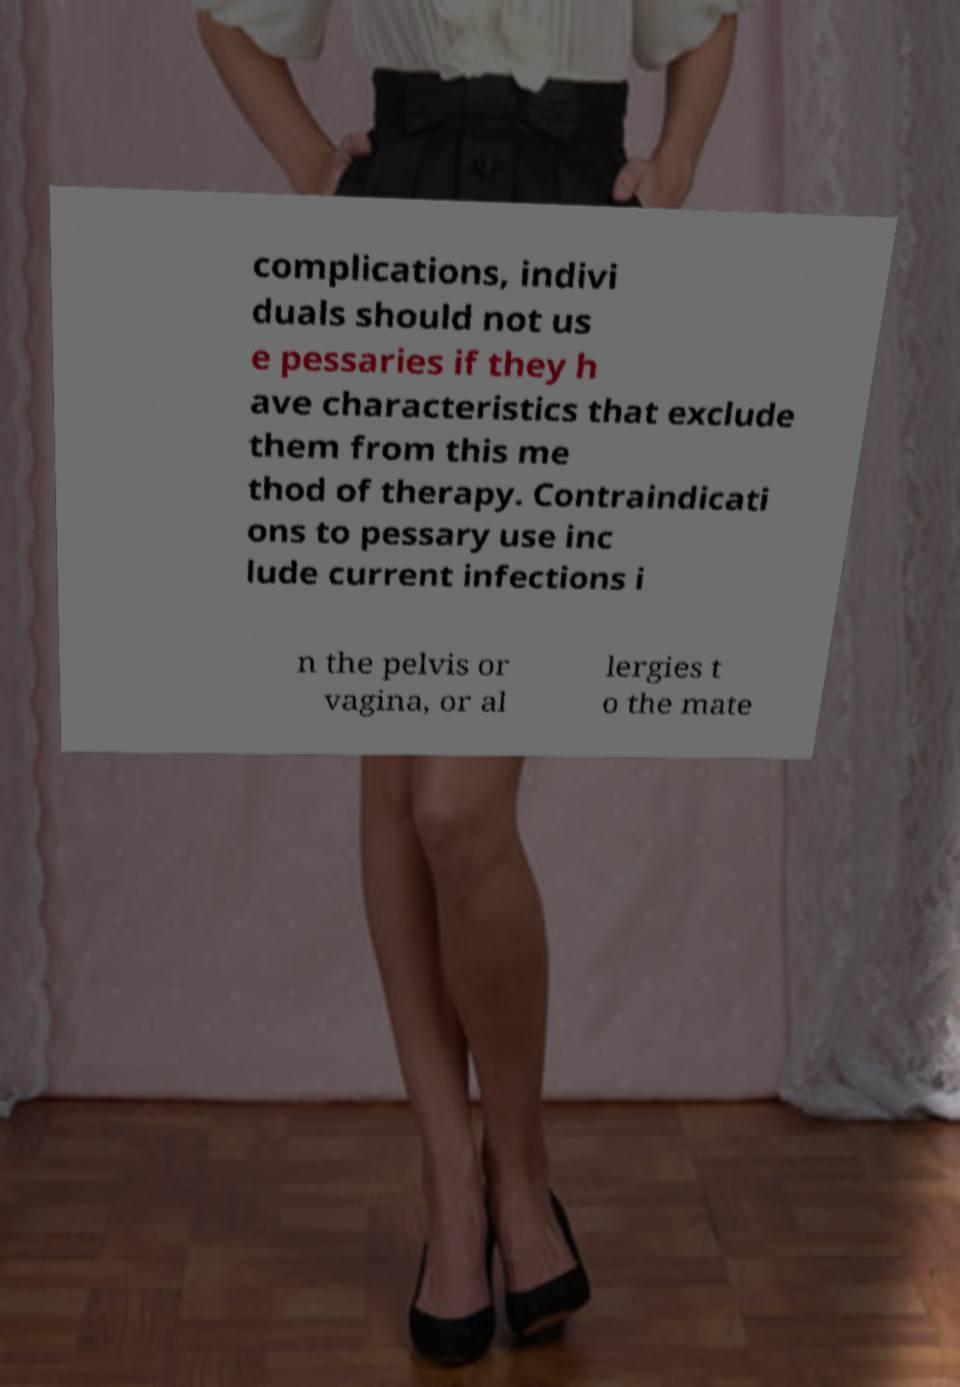Could you extract and type out the text from this image? complications, indivi duals should not us e pessaries if they h ave characteristics that exclude them from this me thod of therapy. Contraindicati ons to pessary use inc lude current infections i n the pelvis or vagina, or al lergies t o the mate 